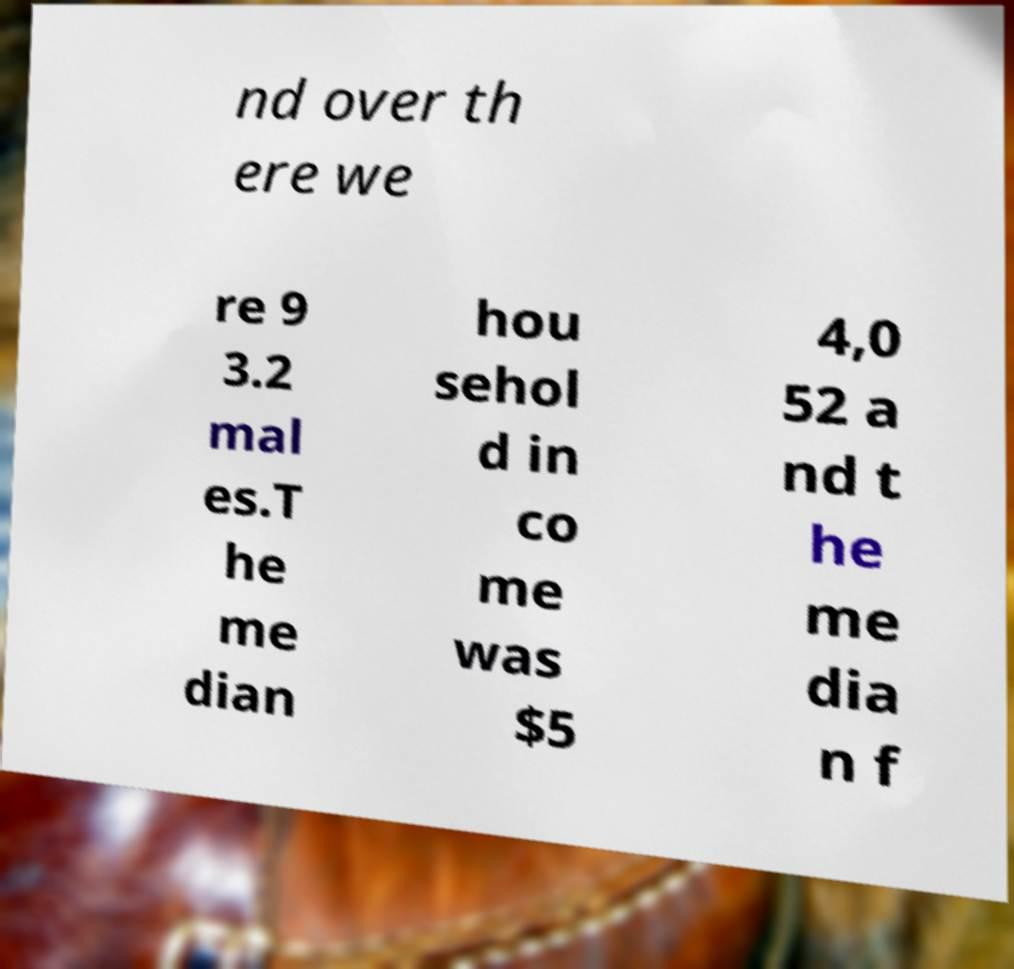I need the written content from this picture converted into text. Can you do that? nd over th ere we re 9 3.2 mal es.T he me dian hou sehol d in co me was $5 4,0 52 a nd t he me dia n f 